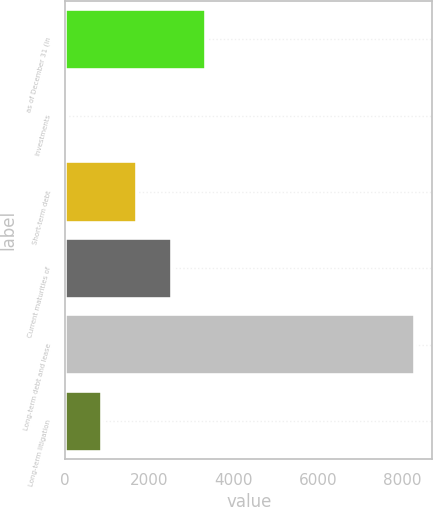Convert chart to OTSL. <chart><loc_0><loc_0><loc_500><loc_500><bar_chart><fcel>as of December 31 (in<fcel>Investments<fcel>Short-term debt<fcel>Current maturities of<fcel>Long-term debt and lease<fcel>Long-term litigation<nl><fcel>3351<fcel>53<fcel>1702<fcel>2526.5<fcel>8298<fcel>877.5<nl></chart> 